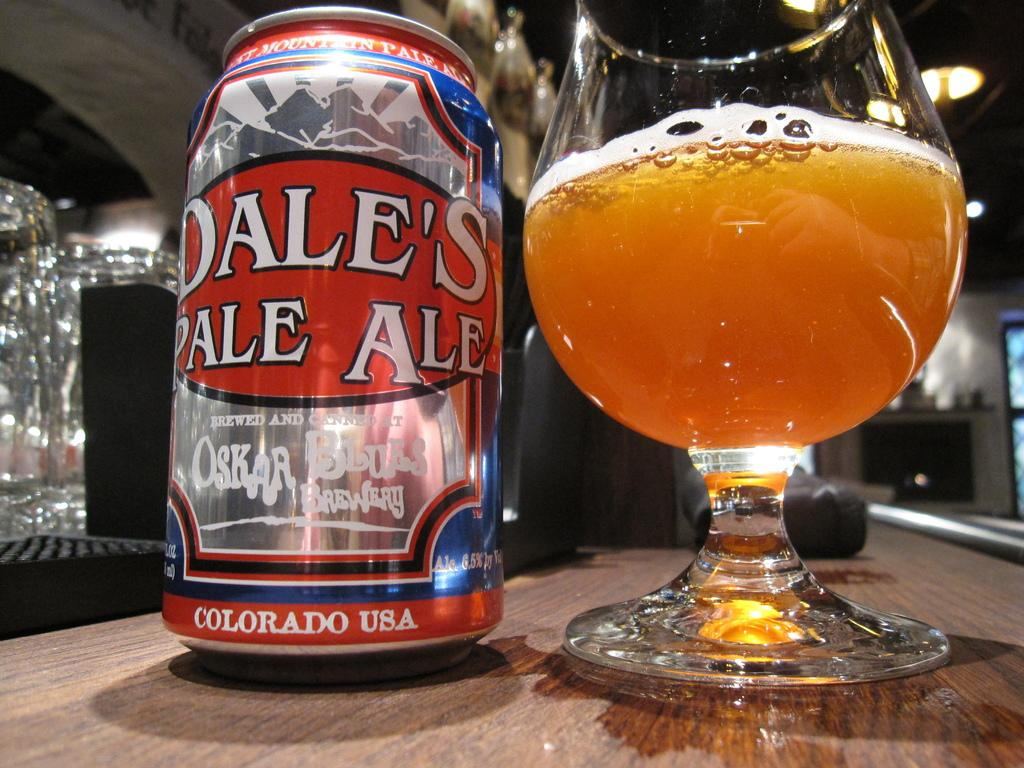Provide a one-sentence caption for the provided image. A glass of Dale's Pale Ale sits next to the can it came in. 